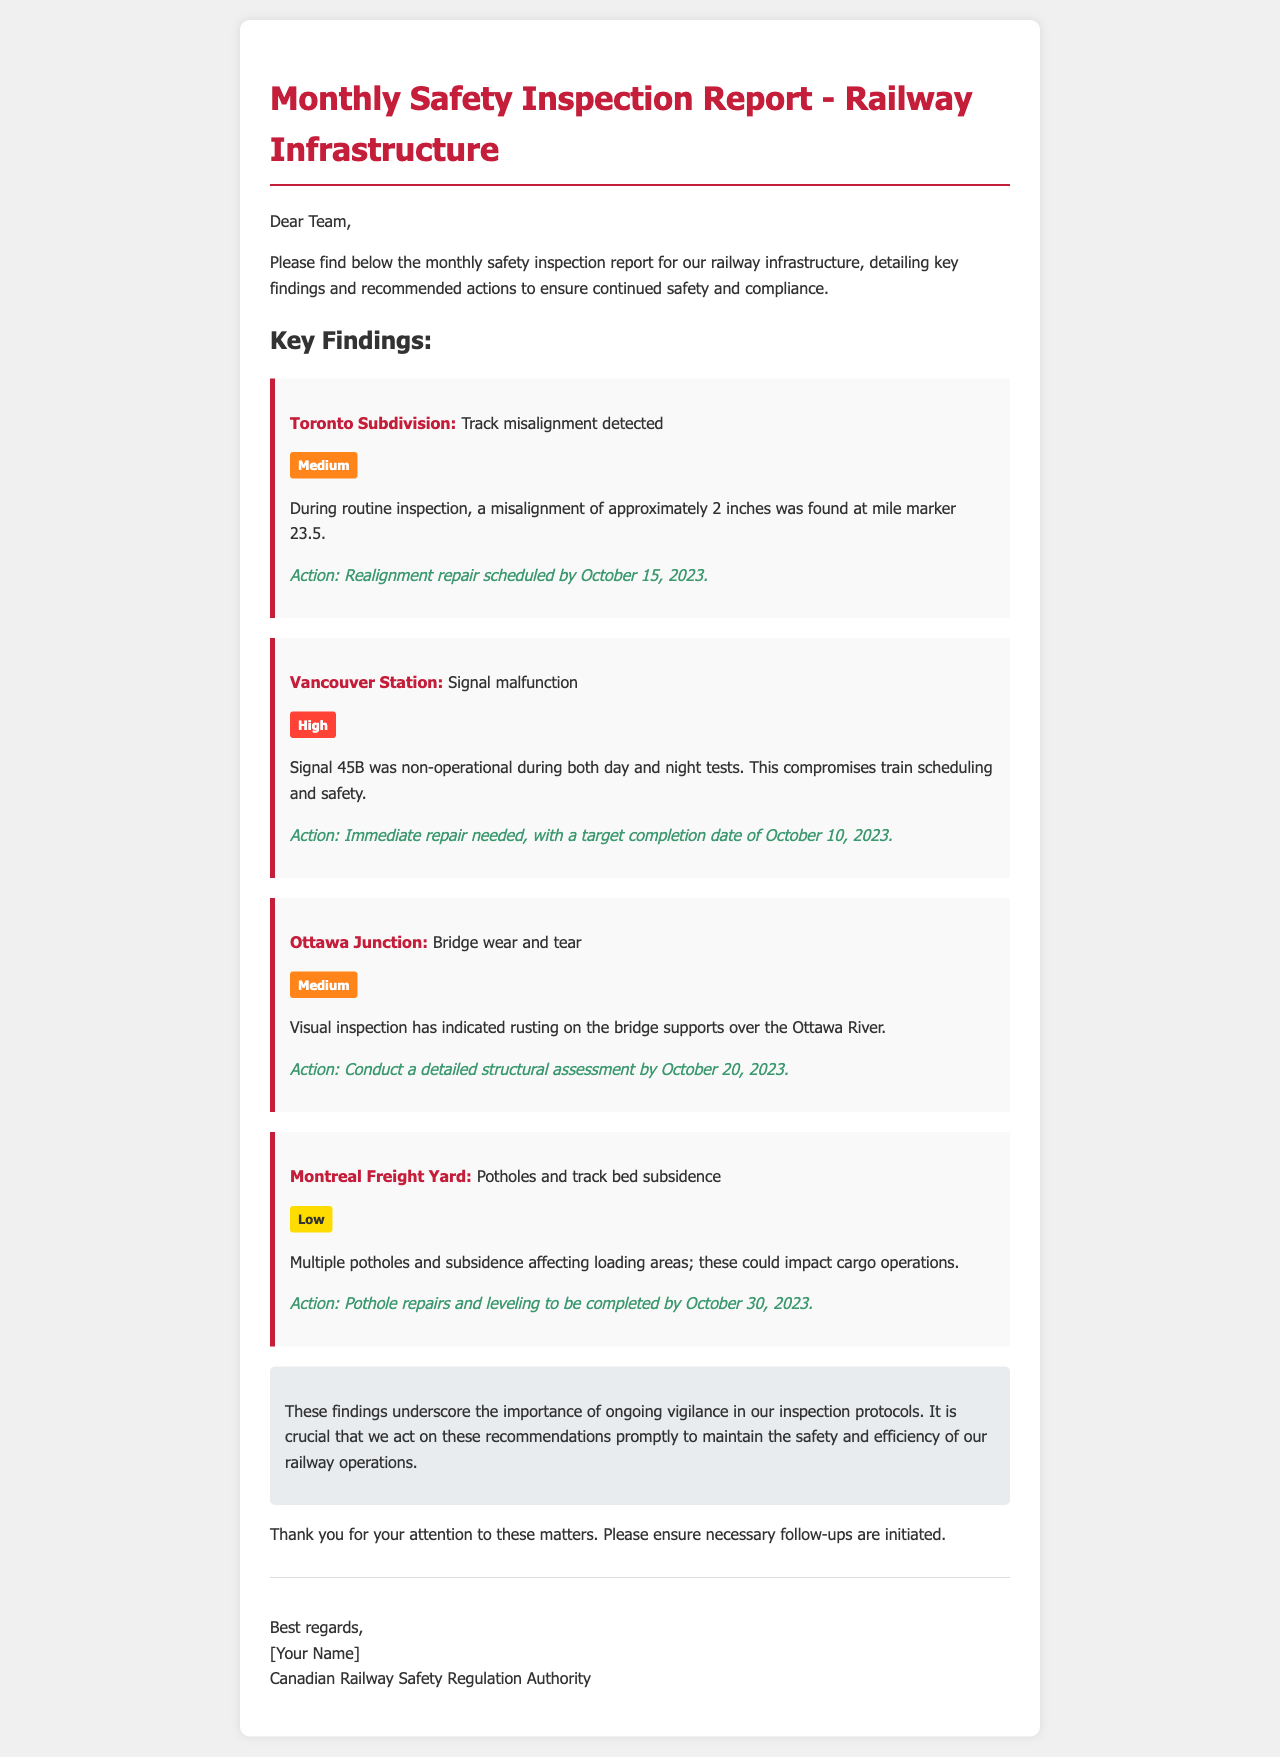what is the date for the realignment repair in Toronto Subdivision? The document states that the realignment repair is scheduled by October 15, 2023, in the Toronto Subdivision finding.
Answer: October 15, 2023 what is the nature of the issue reported at Vancouver Station? The issue reported at Vancouver Station is a signal malfunction involving Signal 45B which was non-operational during inspections.
Answer: Signal malfunction what is the severity level of the bridge wear and tear at Ottawa Junction? The severity level categorized for the bridge wear and tear at Ottawa Junction is Medium, as stated in the findings.
Answer: Medium what action is recommended for the potholes and subsidence at Montreal Freight Yard? The document recommends pothole repairs and leveling to be completed by October 30, 2023, for the Montreal Freight Yard issue.
Answer: Pothole repairs and leveling when is the detailed structural assessment for Ottawa Junction scheduled? The scheduled date for the detailed structural assessment at Ottawa Junction is October 20, 2023, as indicated in the report.
Answer: October 20, 2023 why is the signal malfunction at Vancouver Station marked as high severity? The signal malfunction's high severity is due to its compromise of train scheduling and safety, highlighting its critical nature.
Answer: Compromises train scheduling and safety what is the main conclusion drawn from the findings of the inspection report? The main conclusion emphasizes the importance of ongoing vigilance in inspection protocols and the need for prompt actions.
Answer: Ongoing vigilance and prompt actions how many locations were inspected according to the report? The report details findings from four distinct locations: Toronto Subdivision, Vancouver Station, Ottawa Junction, and Montreal Freight Yard.
Answer: Four locations what should be done regarding the misalignment detected in Toronto Subdivision? The recommended action is a realignment repair scheduled by a specific date to address the misalignment issue.
Answer: Realignment repair 